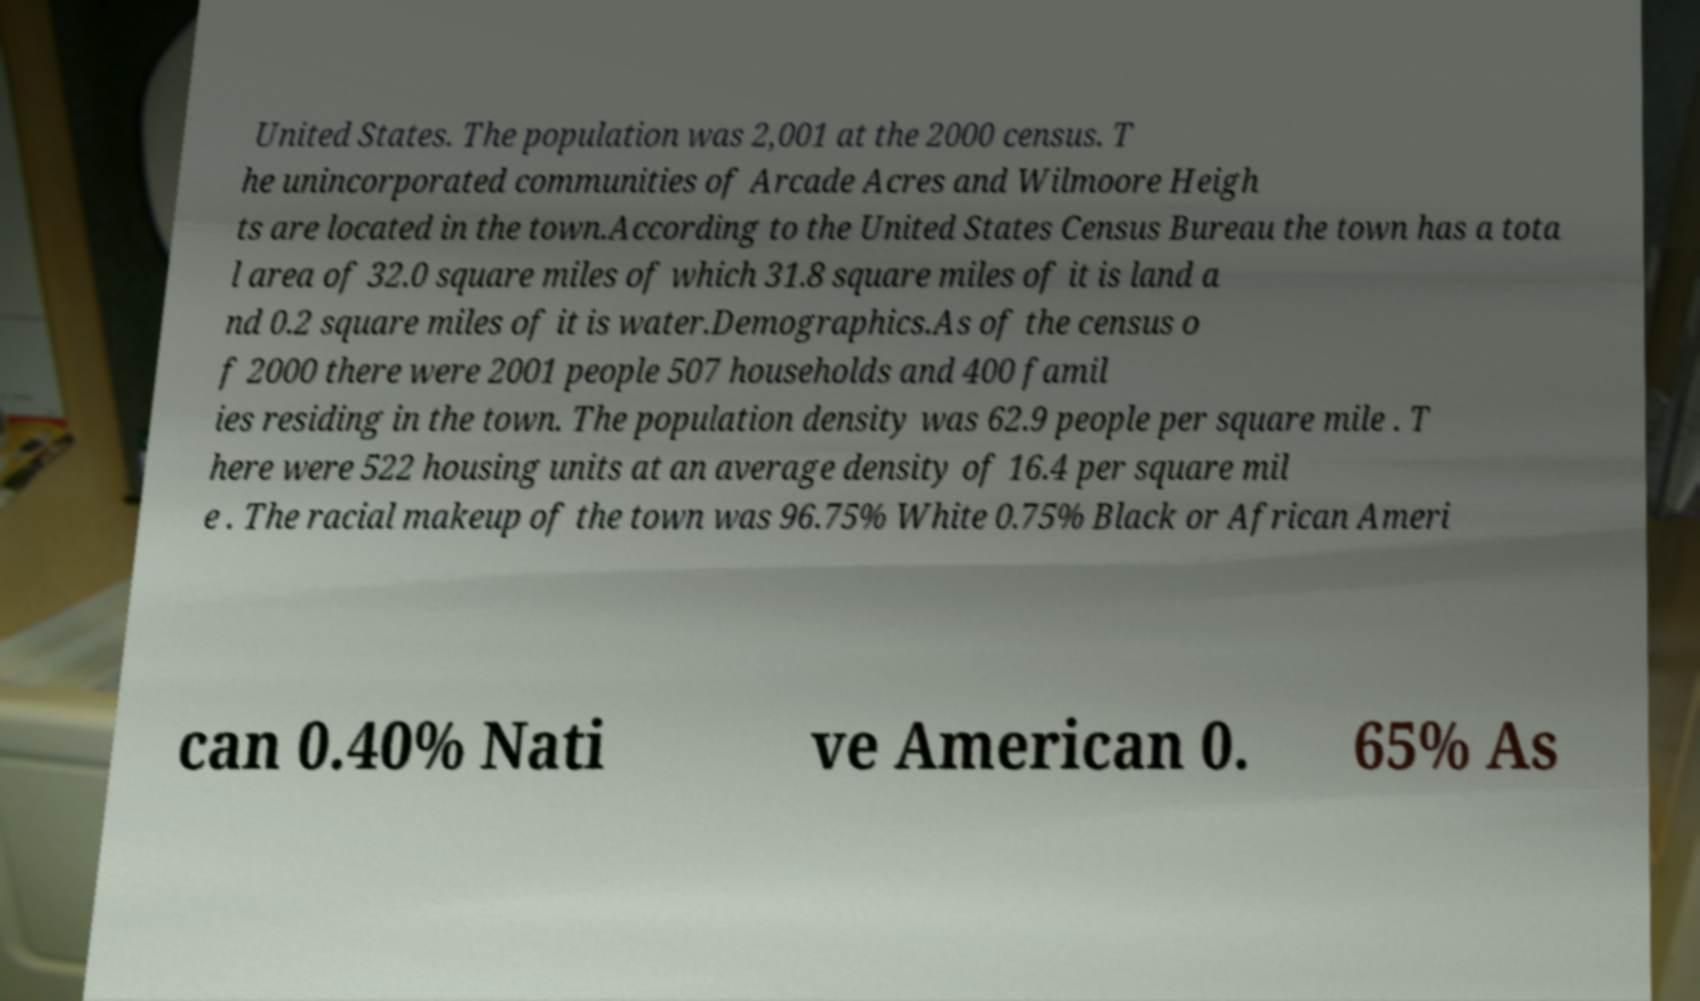Could you extract and type out the text from this image? United States. The population was 2,001 at the 2000 census. T he unincorporated communities of Arcade Acres and Wilmoore Heigh ts are located in the town.According to the United States Census Bureau the town has a tota l area of 32.0 square miles of which 31.8 square miles of it is land a nd 0.2 square miles of it is water.Demographics.As of the census o f 2000 there were 2001 people 507 households and 400 famil ies residing in the town. The population density was 62.9 people per square mile . T here were 522 housing units at an average density of 16.4 per square mil e . The racial makeup of the town was 96.75% White 0.75% Black or African Ameri can 0.40% Nati ve American 0. 65% As 